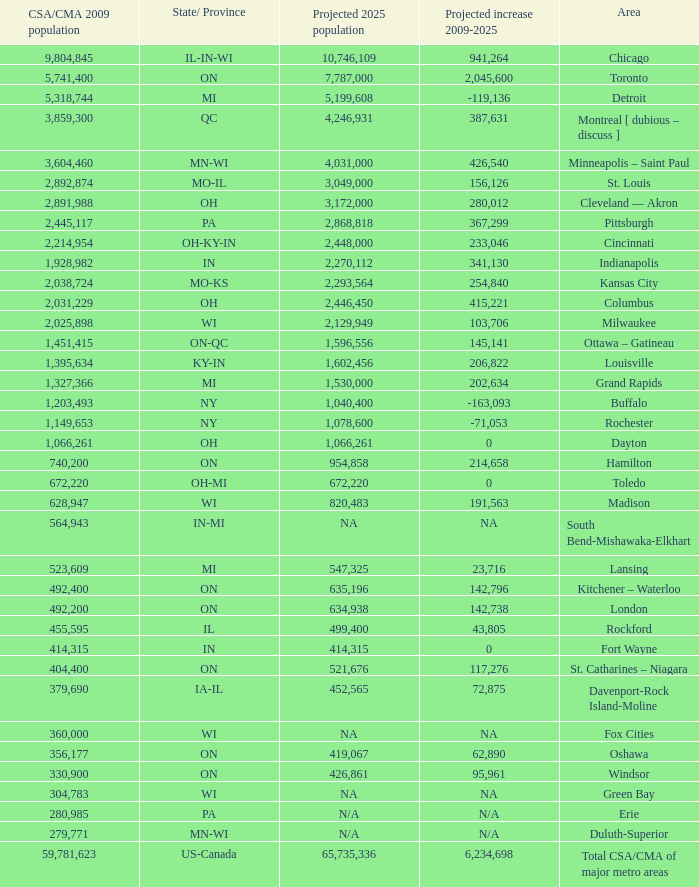What's the projected population of IN-MI? NA. 